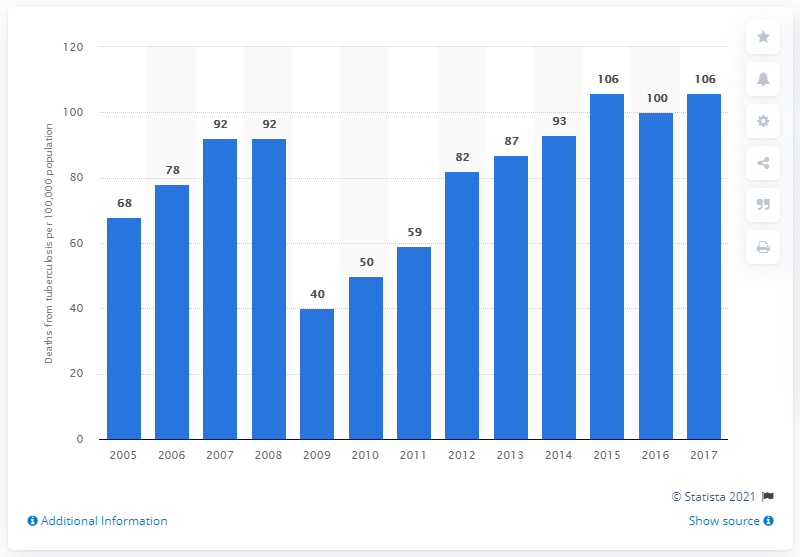Identify some key points in this picture. In 2017, there were 106 deaths from tuberculosis in Timor Leste. 